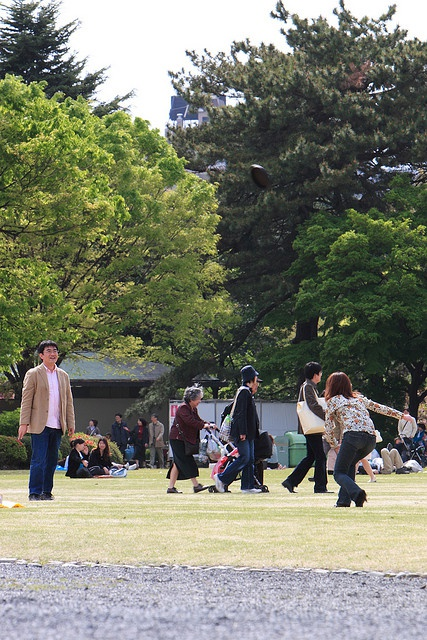Describe the objects in this image and their specific colors. I can see people in white, gray, black, navy, and darkgray tones, people in white, black, darkgray, and lightgray tones, people in white, black, navy, gray, and darkgray tones, people in white, black, gray, and darkgray tones, and people in white, black, and gray tones in this image. 